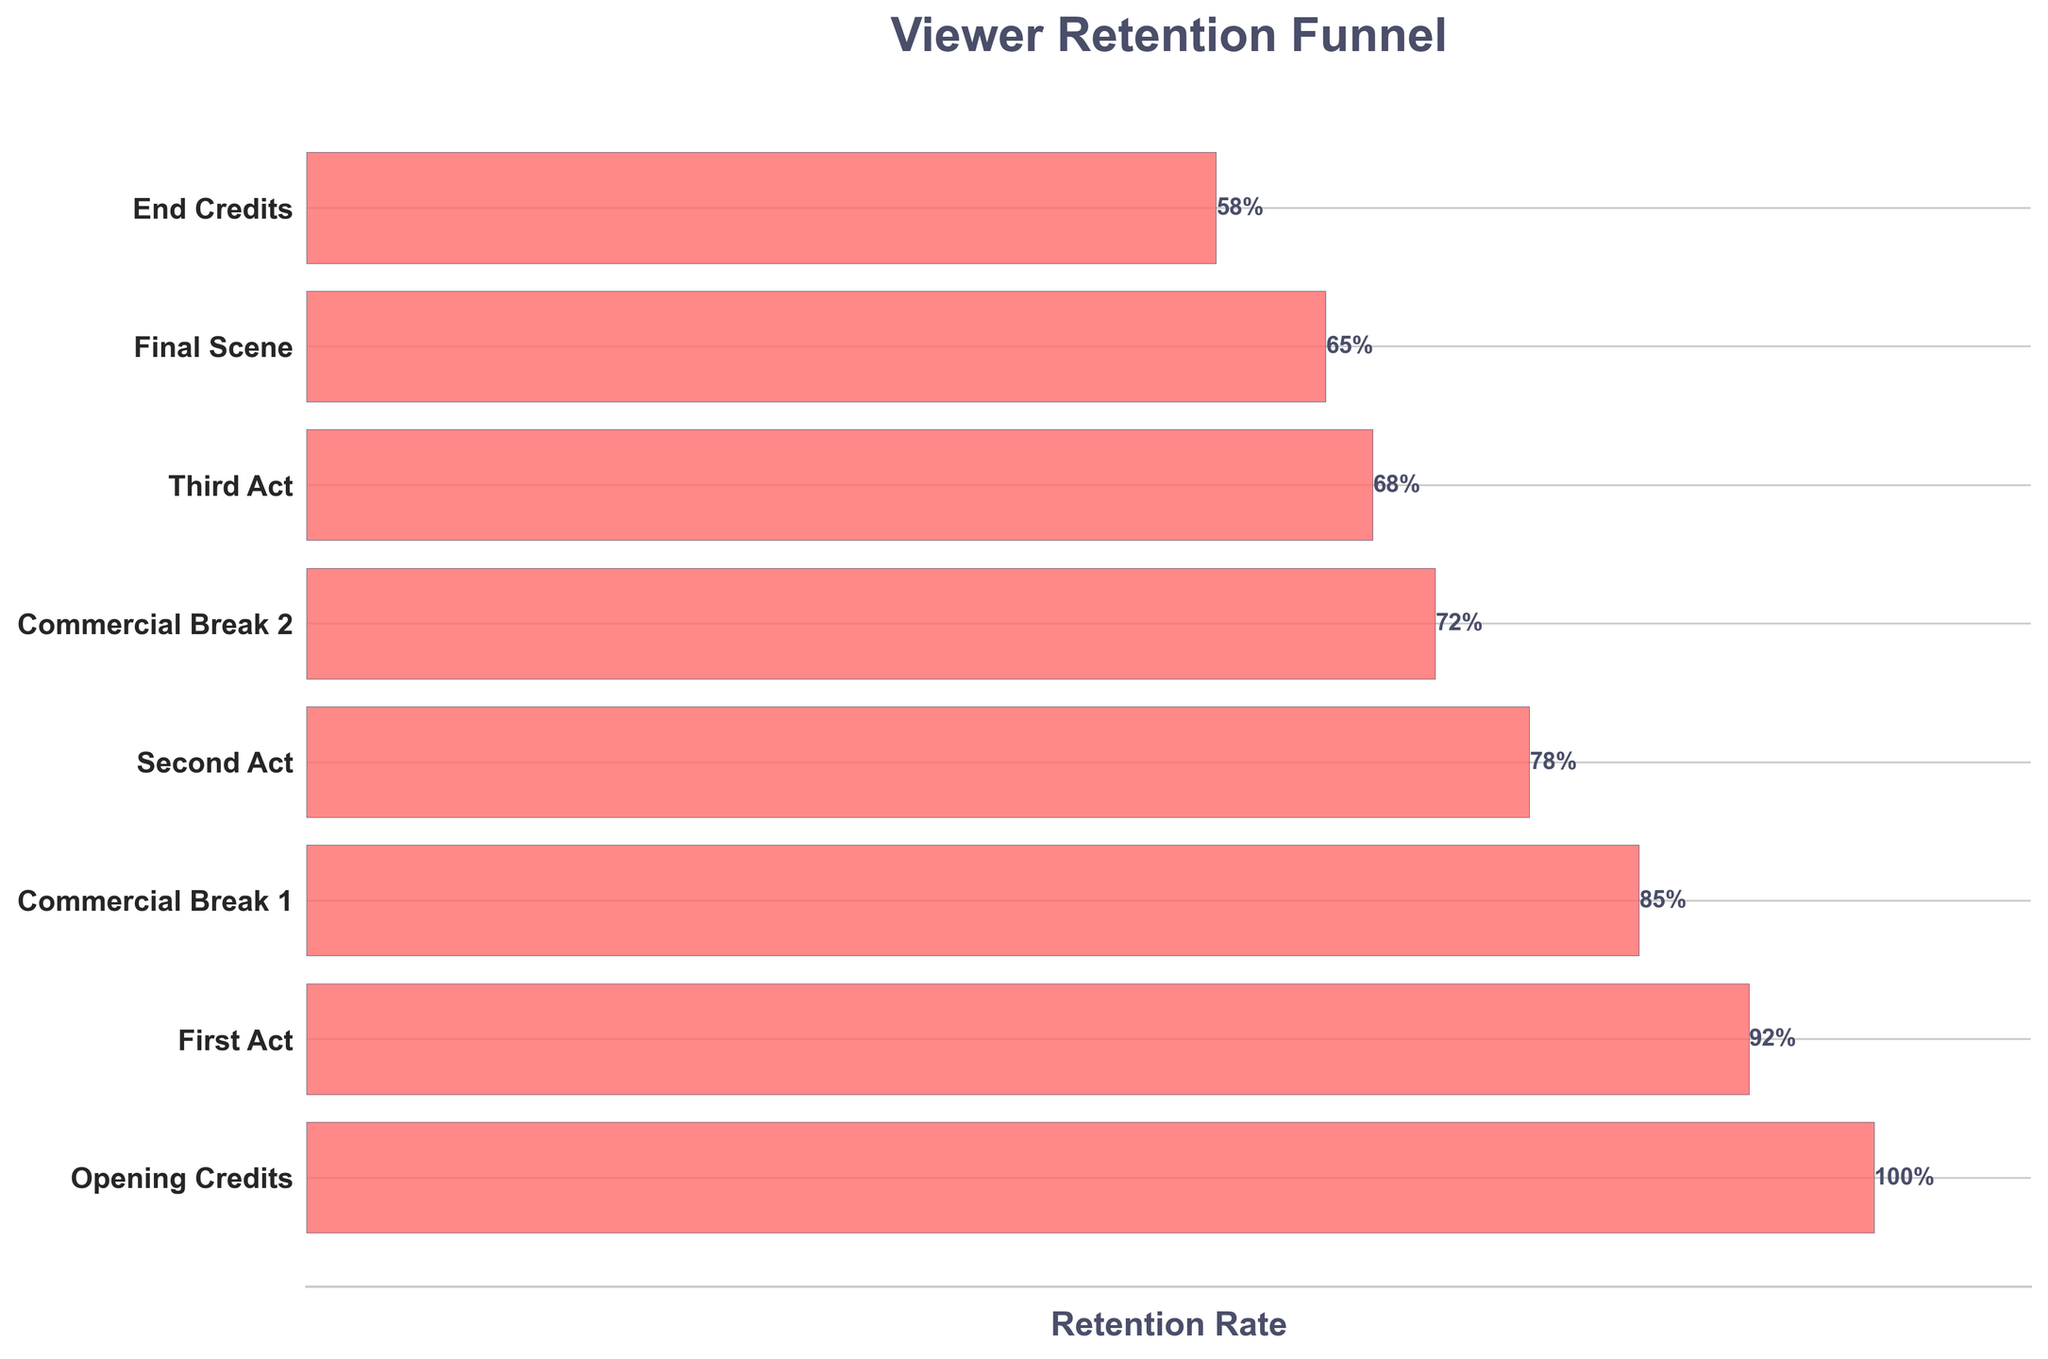What is the title of the chart? The title of the chart is prominently displayed at the top of the figure.
Answer: Viewer Retention Funnel Which segment has the highest retention rate? The segment with the highest retention rate is represented by the widest bar at the top of the funnel.
Answer: Opening Credits What is the retention rate for the Final Scene segment? The retention rate for each segment is displayed as a percentage next to the corresponding bar. Locate the Final Scene and read the percentage.
Answer: 65% How many segments are displayed in the figure? Count the number of horizontal bars in the chart. Each bar represents one segment.
Answer: 8 What is the difference in retention rates between the First Act and the Third Act? Find the retention rates for the First Act (92%) and the Third Act (68%), then subtract the latter from the former to find the difference.
Answer: 24% Which commercial break saw the highest drop in viewer retention? Compare the retention rates before and after each commercial break and identify the one with the largest decrease.
Answer: Commercial Break 1 What is the average retention rate of the segments excluding commercial breaks? Collect the retention rates for Opening Credits, First Act, Second Act, Third Act, Final Scene, and End Credits; then calculate their average: (100+92+78+68+65+58)/6 = 77%.
Answer: 77% Is the retention rate higher in the Second Act or the Final Scene? Compare the retention rates for the Second Act (78%) and the Final Scene (65%).
Answer: Second Act Which segments have a retention rate below 70%? Identify and list all segments with retention rates lower than 70%.
Answer: Third Act, Final Scene, End Credits How does the retention rate change from the Opening Credits to the End Credits? Note the retention rate at the Opening Credits (100%) and the End Credits (58%), and describe the overall trend in viewer retention.
Answer: It decreases 